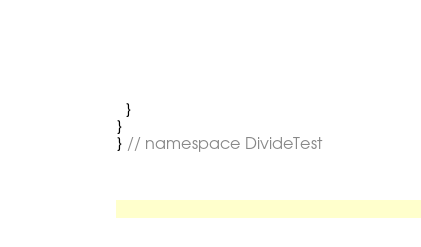<code> <loc_0><loc_0><loc_500><loc_500><_C++_>  }
}
} // namespace DivideTest
</code> 